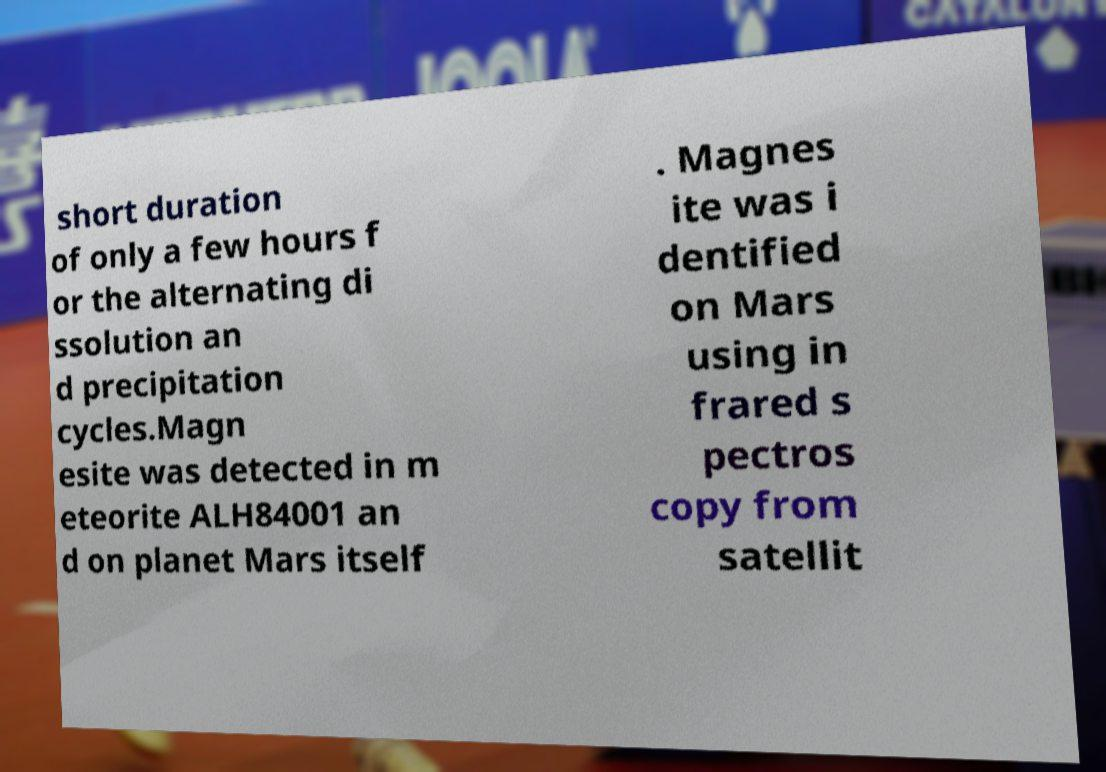Could you extract and type out the text from this image? short duration of only a few hours f or the alternating di ssolution an d precipitation cycles.Magn esite was detected in m eteorite ALH84001 an d on planet Mars itself . Magnes ite was i dentified on Mars using in frared s pectros copy from satellit 